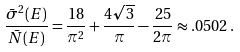Convert formula to latex. <formula><loc_0><loc_0><loc_500><loc_500>\frac { \bar { \sigma } ^ { 2 } ( E ) } { \bar { N } ( E ) } = \frac { 1 8 } { \pi ^ { 2 } } + \frac { 4 \sqrt { 3 } } { \pi } - \frac { 2 5 } { 2 \pi } \approx . 0 5 0 2 \, .</formula> 